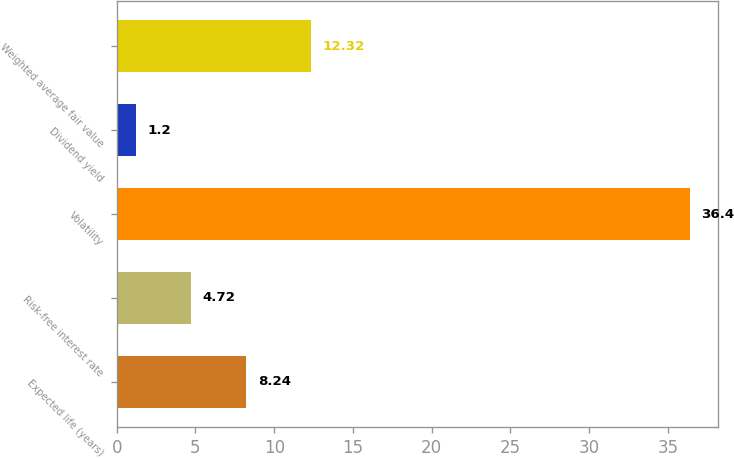Convert chart. <chart><loc_0><loc_0><loc_500><loc_500><bar_chart><fcel>Expected life (years)<fcel>Risk-free interest rate<fcel>Volatility<fcel>Dividend yield<fcel>Weighted average fair value<nl><fcel>8.24<fcel>4.72<fcel>36.4<fcel>1.2<fcel>12.32<nl></chart> 